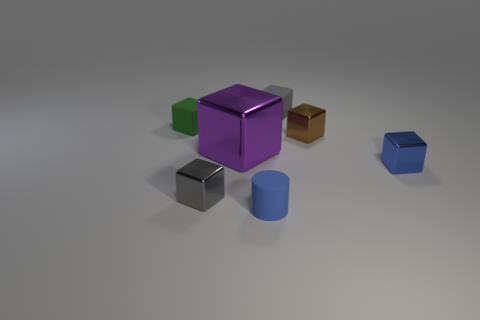Subtract all brown blocks. How many blocks are left? 5 Subtract all tiny green cubes. How many cubes are left? 5 Subtract all yellow cubes. Subtract all blue cylinders. How many cubes are left? 6 Add 1 brown cylinders. How many objects exist? 8 Subtract all blocks. How many objects are left? 1 Subtract 0 red blocks. How many objects are left? 7 Subtract all metal blocks. Subtract all small blue objects. How many objects are left? 1 Add 3 blue cylinders. How many blue cylinders are left? 4 Add 5 green rubber cubes. How many green rubber cubes exist? 6 